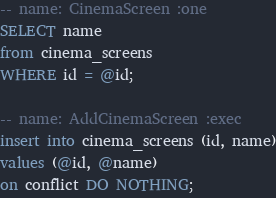<code> <loc_0><loc_0><loc_500><loc_500><_SQL_>-- name: CinemaScreen :one
SELECT name
from cinema_screens
WHERE id = @id;

-- name: AddCinemaScreen :exec
insert into cinema_screens (id, name)
values (@id, @name)
on conflict DO NOTHING;</code> 